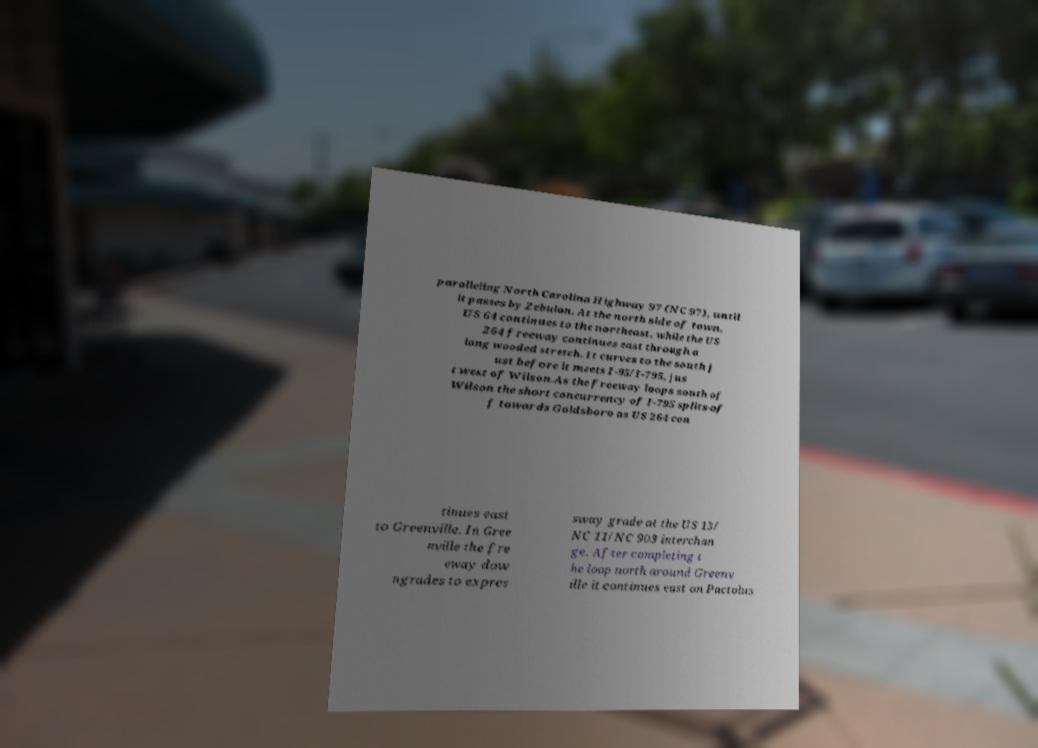Could you extract and type out the text from this image? paralleling North Carolina Highway 97 (NC 97), until it passes by Zebulon. At the north side of town, US 64 continues to the northeast, while the US 264 freeway continues east through a long wooded stretch. It curves to the south j ust before it meets I-95/I-795, jus t west of Wilson.As the freeway loops south of Wilson the short concurrency of I-795 splits-of f towards Goldsboro as US 264 con tinues east to Greenville. In Gree nville the fre eway dow ngrades to expres sway grade at the US 13/ NC 11/NC 903 interchan ge. After completing t he loop north around Greenv ille it continues east on Pactolus 